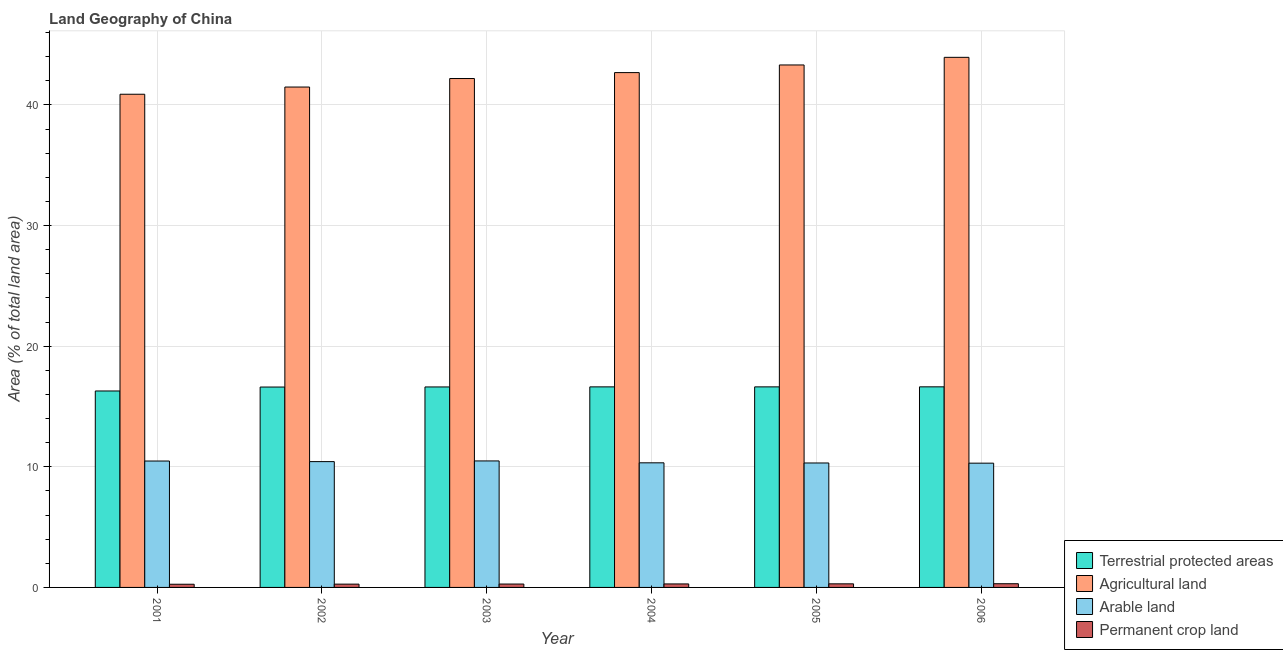How many groups of bars are there?
Provide a succinct answer. 6. Are the number of bars on each tick of the X-axis equal?
Keep it short and to the point. Yes. How many bars are there on the 5th tick from the left?
Give a very brief answer. 4. How many bars are there on the 1st tick from the right?
Provide a succinct answer. 4. In how many cases, is the number of bars for a given year not equal to the number of legend labels?
Offer a terse response. 0. What is the percentage of area under permanent crop land in 2004?
Provide a short and direct response. 0.29. Across all years, what is the maximum percentage of land under terrestrial protection?
Keep it short and to the point. 16.63. Across all years, what is the minimum percentage of area under permanent crop land?
Offer a terse response. 0.26. In which year was the percentage of area under permanent crop land minimum?
Keep it short and to the point. 2001. What is the total percentage of land under terrestrial protection in the graph?
Your answer should be compact. 99.41. What is the difference between the percentage of area under permanent crop land in 2002 and that in 2006?
Make the answer very short. -0.03. What is the difference between the percentage of area under arable land in 2003 and the percentage of area under agricultural land in 2001?
Offer a very short reply. 0.01. What is the average percentage of area under agricultural land per year?
Your answer should be very brief. 42.42. In the year 2002, what is the difference between the percentage of land under terrestrial protection and percentage of area under agricultural land?
Provide a short and direct response. 0. What is the ratio of the percentage of area under permanent crop land in 2004 to that in 2006?
Your answer should be very brief. 0.94. Is the difference between the percentage of area under agricultural land in 2003 and 2006 greater than the difference between the percentage of land under terrestrial protection in 2003 and 2006?
Provide a succinct answer. No. What is the difference between the highest and the second highest percentage of area under arable land?
Make the answer very short. 0.01. What is the difference between the highest and the lowest percentage of area under arable land?
Ensure brevity in your answer.  0.19. Is the sum of the percentage of area under agricultural land in 2001 and 2005 greater than the maximum percentage of area under arable land across all years?
Make the answer very short. Yes. Is it the case that in every year, the sum of the percentage of area under arable land and percentage of area under permanent crop land is greater than the sum of percentage of land under terrestrial protection and percentage of area under agricultural land?
Your answer should be very brief. No. What does the 2nd bar from the left in 2005 represents?
Keep it short and to the point. Agricultural land. What does the 3rd bar from the right in 2001 represents?
Your answer should be compact. Agricultural land. How many bars are there?
Give a very brief answer. 24. Are all the bars in the graph horizontal?
Offer a terse response. No. Are the values on the major ticks of Y-axis written in scientific E-notation?
Ensure brevity in your answer.  No. Does the graph contain grids?
Ensure brevity in your answer.  Yes. Where does the legend appear in the graph?
Make the answer very short. Bottom right. How are the legend labels stacked?
Provide a short and direct response. Vertical. What is the title of the graph?
Offer a very short reply. Land Geography of China. What is the label or title of the X-axis?
Offer a very short reply. Year. What is the label or title of the Y-axis?
Give a very brief answer. Area (% of total land area). What is the Area (% of total land area) in Terrestrial protected areas in 2001?
Offer a very short reply. 16.29. What is the Area (% of total land area) in Agricultural land in 2001?
Make the answer very short. 40.89. What is the Area (% of total land area) of Arable land in 2001?
Provide a succinct answer. 10.48. What is the Area (% of total land area) in Permanent crop land in 2001?
Offer a terse response. 0.26. What is the Area (% of total land area) of Terrestrial protected areas in 2002?
Your answer should be compact. 16.61. What is the Area (% of total land area) of Agricultural land in 2002?
Provide a succinct answer. 41.49. What is the Area (% of total land area) in Arable land in 2002?
Your answer should be compact. 10.43. What is the Area (% of total land area) of Permanent crop land in 2002?
Ensure brevity in your answer.  0.27. What is the Area (% of total land area) of Terrestrial protected areas in 2003?
Ensure brevity in your answer.  16.62. What is the Area (% of total land area) in Agricultural land in 2003?
Your answer should be compact. 42.19. What is the Area (% of total land area) in Arable land in 2003?
Your response must be concise. 10.49. What is the Area (% of total land area) of Permanent crop land in 2003?
Your answer should be very brief. 0.28. What is the Area (% of total land area) of Terrestrial protected areas in 2004?
Ensure brevity in your answer.  16.63. What is the Area (% of total land area) of Agricultural land in 2004?
Provide a short and direct response. 42.68. What is the Area (% of total land area) of Arable land in 2004?
Ensure brevity in your answer.  10.33. What is the Area (% of total land area) of Permanent crop land in 2004?
Your response must be concise. 0.29. What is the Area (% of total land area) of Terrestrial protected areas in 2005?
Offer a very short reply. 16.63. What is the Area (% of total land area) in Agricultural land in 2005?
Keep it short and to the point. 43.32. What is the Area (% of total land area) in Arable land in 2005?
Your response must be concise. 10.32. What is the Area (% of total land area) in Permanent crop land in 2005?
Your response must be concise. 0.3. What is the Area (% of total land area) in Terrestrial protected areas in 2006?
Provide a succinct answer. 16.63. What is the Area (% of total land area) in Agricultural land in 2006?
Your answer should be compact. 43.95. What is the Area (% of total land area) in Arable land in 2006?
Ensure brevity in your answer.  10.3. What is the Area (% of total land area) of Permanent crop land in 2006?
Ensure brevity in your answer.  0.31. Across all years, what is the maximum Area (% of total land area) in Terrestrial protected areas?
Your response must be concise. 16.63. Across all years, what is the maximum Area (% of total land area) in Agricultural land?
Your answer should be compact. 43.95. Across all years, what is the maximum Area (% of total land area) in Arable land?
Provide a short and direct response. 10.49. Across all years, what is the maximum Area (% of total land area) of Permanent crop land?
Your answer should be very brief. 0.31. Across all years, what is the minimum Area (% of total land area) of Terrestrial protected areas?
Offer a very short reply. 16.29. Across all years, what is the minimum Area (% of total land area) of Agricultural land?
Ensure brevity in your answer.  40.89. Across all years, what is the minimum Area (% of total land area) in Arable land?
Your answer should be very brief. 10.3. Across all years, what is the minimum Area (% of total land area) of Permanent crop land?
Your answer should be very brief. 0.26. What is the total Area (% of total land area) in Terrestrial protected areas in the graph?
Offer a very short reply. 99.41. What is the total Area (% of total land area) in Agricultural land in the graph?
Offer a very short reply. 254.51. What is the total Area (% of total land area) in Arable land in the graph?
Ensure brevity in your answer.  62.35. What is the total Area (% of total land area) in Permanent crop land in the graph?
Provide a short and direct response. 1.71. What is the difference between the Area (% of total land area) of Terrestrial protected areas in 2001 and that in 2002?
Provide a succinct answer. -0.33. What is the difference between the Area (% of total land area) of Agricultural land in 2001 and that in 2002?
Your answer should be compact. -0.6. What is the difference between the Area (% of total land area) in Arable land in 2001 and that in 2002?
Your answer should be very brief. 0.05. What is the difference between the Area (% of total land area) in Permanent crop land in 2001 and that in 2002?
Provide a succinct answer. -0.01. What is the difference between the Area (% of total land area) of Terrestrial protected areas in 2001 and that in 2003?
Give a very brief answer. -0.33. What is the difference between the Area (% of total land area) of Agricultural land in 2001 and that in 2003?
Keep it short and to the point. -1.3. What is the difference between the Area (% of total land area) of Arable land in 2001 and that in 2003?
Your response must be concise. -0.01. What is the difference between the Area (% of total land area) in Permanent crop land in 2001 and that in 2003?
Provide a succinct answer. -0.02. What is the difference between the Area (% of total land area) in Terrestrial protected areas in 2001 and that in 2004?
Offer a terse response. -0.34. What is the difference between the Area (% of total land area) in Agricultural land in 2001 and that in 2004?
Your answer should be compact. -1.79. What is the difference between the Area (% of total land area) of Arable land in 2001 and that in 2004?
Your response must be concise. 0.15. What is the difference between the Area (% of total land area) in Permanent crop land in 2001 and that in 2004?
Make the answer very short. -0.03. What is the difference between the Area (% of total land area) of Terrestrial protected areas in 2001 and that in 2005?
Provide a short and direct response. -0.34. What is the difference between the Area (% of total land area) in Agricultural land in 2001 and that in 2005?
Your answer should be very brief. -2.43. What is the difference between the Area (% of total land area) of Arable land in 2001 and that in 2005?
Make the answer very short. 0.16. What is the difference between the Area (% of total land area) in Permanent crop land in 2001 and that in 2005?
Provide a succinct answer. -0.03. What is the difference between the Area (% of total land area) in Terrestrial protected areas in 2001 and that in 2006?
Offer a very short reply. -0.34. What is the difference between the Area (% of total land area) of Agricultural land in 2001 and that in 2006?
Your answer should be very brief. -3.06. What is the difference between the Area (% of total land area) of Arable land in 2001 and that in 2006?
Your answer should be compact. 0.18. What is the difference between the Area (% of total land area) in Permanent crop land in 2001 and that in 2006?
Provide a short and direct response. -0.04. What is the difference between the Area (% of total land area) of Terrestrial protected areas in 2002 and that in 2003?
Your answer should be compact. -0.01. What is the difference between the Area (% of total land area) of Agricultural land in 2002 and that in 2003?
Make the answer very short. -0.71. What is the difference between the Area (% of total land area) of Arable land in 2002 and that in 2003?
Provide a short and direct response. -0.06. What is the difference between the Area (% of total land area) of Permanent crop land in 2002 and that in 2003?
Your response must be concise. -0.01. What is the difference between the Area (% of total land area) in Terrestrial protected areas in 2002 and that in 2004?
Give a very brief answer. -0.02. What is the difference between the Area (% of total land area) in Agricultural land in 2002 and that in 2004?
Offer a terse response. -1.2. What is the difference between the Area (% of total land area) of Arable land in 2002 and that in 2004?
Provide a succinct answer. 0.1. What is the difference between the Area (% of total land area) of Permanent crop land in 2002 and that in 2004?
Your answer should be compact. -0.02. What is the difference between the Area (% of total land area) in Terrestrial protected areas in 2002 and that in 2005?
Make the answer very short. -0.02. What is the difference between the Area (% of total land area) of Agricultural land in 2002 and that in 2005?
Provide a short and direct response. -1.83. What is the difference between the Area (% of total land area) in Arable land in 2002 and that in 2005?
Your answer should be compact. 0.11. What is the difference between the Area (% of total land area) of Permanent crop land in 2002 and that in 2005?
Make the answer very short. -0.03. What is the difference between the Area (% of total land area) of Terrestrial protected areas in 2002 and that in 2006?
Make the answer very short. -0.02. What is the difference between the Area (% of total land area) of Agricultural land in 2002 and that in 2006?
Give a very brief answer. -2.46. What is the difference between the Area (% of total land area) of Arable land in 2002 and that in 2006?
Keep it short and to the point. 0.13. What is the difference between the Area (% of total land area) of Permanent crop land in 2002 and that in 2006?
Your answer should be compact. -0.03. What is the difference between the Area (% of total land area) in Terrestrial protected areas in 2003 and that in 2004?
Give a very brief answer. -0.01. What is the difference between the Area (% of total land area) of Agricultural land in 2003 and that in 2004?
Your response must be concise. -0.49. What is the difference between the Area (% of total land area) in Arable land in 2003 and that in 2004?
Offer a terse response. 0.16. What is the difference between the Area (% of total land area) in Permanent crop land in 2003 and that in 2004?
Make the answer very short. -0.01. What is the difference between the Area (% of total land area) in Terrestrial protected areas in 2003 and that in 2005?
Your answer should be compact. -0.01. What is the difference between the Area (% of total land area) of Agricultural land in 2003 and that in 2005?
Offer a terse response. -1.12. What is the difference between the Area (% of total land area) of Arable land in 2003 and that in 2005?
Offer a very short reply. 0.17. What is the difference between the Area (% of total land area) in Permanent crop land in 2003 and that in 2005?
Your answer should be compact. -0.02. What is the difference between the Area (% of total land area) of Terrestrial protected areas in 2003 and that in 2006?
Offer a very short reply. -0.01. What is the difference between the Area (% of total land area) in Agricultural land in 2003 and that in 2006?
Offer a terse response. -1.76. What is the difference between the Area (% of total land area) of Arable land in 2003 and that in 2006?
Offer a very short reply. 0.19. What is the difference between the Area (% of total land area) in Permanent crop land in 2003 and that in 2006?
Your answer should be very brief. -0.03. What is the difference between the Area (% of total land area) in Terrestrial protected areas in 2004 and that in 2005?
Offer a very short reply. -0. What is the difference between the Area (% of total land area) in Agricultural land in 2004 and that in 2005?
Your answer should be compact. -0.63. What is the difference between the Area (% of total land area) in Arable land in 2004 and that in 2005?
Your answer should be compact. 0.01. What is the difference between the Area (% of total land area) in Permanent crop land in 2004 and that in 2005?
Ensure brevity in your answer.  -0.01. What is the difference between the Area (% of total land area) in Terrestrial protected areas in 2004 and that in 2006?
Give a very brief answer. -0. What is the difference between the Area (% of total land area) of Agricultural land in 2004 and that in 2006?
Keep it short and to the point. -1.27. What is the difference between the Area (% of total land area) of Arable land in 2004 and that in 2006?
Your answer should be very brief. 0.03. What is the difference between the Area (% of total land area) in Permanent crop land in 2004 and that in 2006?
Your answer should be compact. -0.02. What is the difference between the Area (% of total land area) of Terrestrial protected areas in 2005 and that in 2006?
Your response must be concise. -0. What is the difference between the Area (% of total land area) of Agricultural land in 2005 and that in 2006?
Your answer should be very brief. -0.63. What is the difference between the Area (% of total land area) in Arable land in 2005 and that in 2006?
Provide a short and direct response. 0.01. What is the difference between the Area (% of total land area) of Permanent crop land in 2005 and that in 2006?
Give a very brief answer. -0.01. What is the difference between the Area (% of total land area) of Terrestrial protected areas in 2001 and the Area (% of total land area) of Agricultural land in 2002?
Your answer should be very brief. -25.2. What is the difference between the Area (% of total land area) of Terrestrial protected areas in 2001 and the Area (% of total land area) of Arable land in 2002?
Your answer should be very brief. 5.86. What is the difference between the Area (% of total land area) of Terrestrial protected areas in 2001 and the Area (% of total land area) of Permanent crop land in 2002?
Make the answer very short. 16.01. What is the difference between the Area (% of total land area) in Agricultural land in 2001 and the Area (% of total land area) in Arable land in 2002?
Make the answer very short. 30.46. What is the difference between the Area (% of total land area) of Agricultural land in 2001 and the Area (% of total land area) of Permanent crop land in 2002?
Your answer should be very brief. 40.62. What is the difference between the Area (% of total land area) in Arable land in 2001 and the Area (% of total land area) in Permanent crop land in 2002?
Provide a short and direct response. 10.21. What is the difference between the Area (% of total land area) in Terrestrial protected areas in 2001 and the Area (% of total land area) in Agricultural land in 2003?
Make the answer very short. -25.9. What is the difference between the Area (% of total land area) of Terrestrial protected areas in 2001 and the Area (% of total land area) of Permanent crop land in 2003?
Make the answer very short. 16.01. What is the difference between the Area (% of total land area) in Agricultural land in 2001 and the Area (% of total land area) in Arable land in 2003?
Ensure brevity in your answer.  30.4. What is the difference between the Area (% of total land area) of Agricultural land in 2001 and the Area (% of total land area) of Permanent crop land in 2003?
Your response must be concise. 40.61. What is the difference between the Area (% of total land area) in Arable land in 2001 and the Area (% of total land area) in Permanent crop land in 2003?
Keep it short and to the point. 10.2. What is the difference between the Area (% of total land area) in Terrestrial protected areas in 2001 and the Area (% of total land area) in Agricultural land in 2004?
Offer a very short reply. -26.39. What is the difference between the Area (% of total land area) in Terrestrial protected areas in 2001 and the Area (% of total land area) in Arable land in 2004?
Your answer should be very brief. 5.96. What is the difference between the Area (% of total land area) of Terrestrial protected areas in 2001 and the Area (% of total land area) of Permanent crop land in 2004?
Your response must be concise. 16. What is the difference between the Area (% of total land area) in Agricultural land in 2001 and the Area (% of total land area) in Arable land in 2004?
Provide a succinct answer. 30.56. What is the difference between the Area (% of total land area) in Agricultural land in 2001 and the Area (% of total land area) in Permanent crop land in 2004?
Your answer should be compact. 40.6. What is the difference between the Area (% of total land area) of Arable land in 2001 and the Area (% of total land area) of Permanent crop land in 2004?
Make the answer very short. 10.19. What is the difference between the Area (% of total land area) in Terrestrial protected areas in 2001 and the Area (% of total land area) in Agricultural land in 2005?
Ensure brevity in your answer.  -27.03. What is the difference between the Area (% of total land area) of Terrestrial protected areas in 2001 and the Area (% of total land area) of Arable land in 2005?
Provide a short and direct response. 5.97. What is the difference between the Area (% of total land area) of Terrestrial protected areas in 2001 and the Area (% of total land area) of Permanent crop land in 2005?
Your answer should be very brief. 15.99. What is the difference between the Area (% of total land area) in Agricultural land in 2001 and the Area (% of total land area) in Arable land in 2005?
Offer a very short reply. 30.57. What is the difference between the Area (% of total land area) of Agricultural land in 2001 and the Area (% of total land area) of Permanent crop land in 2005?
Your response must be concise. 40.59. What is the difference between the Area (% of total land area) in Arable land in 2001 and the Area (% of total land area) in Permanent crop land in 2005?
Ensure brevity in your answer.  10.18. What is the difference between the Area (% of total land area) of Terrestrial protected areas in 2001 and the Area (% of total land area) of Agricultural land in 2006?
Provide a succinct answer. -27.66. What is the difference between the Area (% of total land area) of Terrestrial protected areas in 2001 and the Area (% of total land area) of Arable land in 2006?
Provide a short and direct response. 5.99. What is the difference between the Area (% of total land area) in Terrestrial protected areas in 2001 and the Area (% of total land area) in Permanent crop land in 2006?
Offer a terse response. 15.98. What is the difference between the Area (% of total land area) of Agricultural land in 2001 and the Area (% of total land area) of Arable land in 2006?
Make the answer very short. 30.59. What is the difference between the Area (% of total land area) of Agricultural land in 2001 and the Area (% of total land area) of Permanent crop land in 2006?
Your response must be concise. 40.58. What is the difference between the Area (% of total land area) in Arable land in 2001 and the Area (% of total land area) in Permanent crop land in 2006?
Give a very brief answer. 10.17. What is the difference between the Area (% of total land area) of Terrestrial protected areas in 2002 and the Area (% of total land area) of Agricultural land in 2003?
Offer a very short reply. -25.58. What is the difference between the Area (% of total land area) in Terrestrial protected areas in 2002 and the Area (% of total land area) in Arable land in 2003?
Give a very brief answer. 6.13. What is the difference between the Area (% of total land area) of Terrestrial protected areas in 2002 and the Area (% of total land area) of Permanent crop land in 2003?
Make the answer very short. 16.33. What is the difference between the Area (% of total land area) of Agricultural land in 2002 and the Area (% of total land area) of Arable land in 2003?
Your answer should be compact. 31. What is the difference between the Area (% of total land area) of Agricultural land in 2002 and the Area (% of total land area) of Permanent crop land in 2003?
Ensure brevity in your answer.  41.2. What is the difference between the Area (% of total land area) in Arable land in 2002 and the Area (% of total land area) in Permanent crop land in 2003?
Your answer should be compact. 10.15. What is the difference between the Area (% of total land area) in Terrestrial protected areas in 2002 and the Area (% of total land area) in Agricultural land in 2004?
Keep it short and to the point. -26.07. What is the difference between the Area (% of total land area) of Terrestrial protected areas in 2002 and the Area (% of total land area) of Arable land in 2004?
Keep it short and to the point. 6.28. What is the difference between the Area (% of total land area) in Terrestrial protected areas in 2002 and the Area (% of total land area) in Permanent crop land in 2004?
Offer a very short reply. 16.32. What is the difference between the Area (% of total land area) of Agricultural land in 2002 and the Area (% of total land area) of Arable land in 2004?
Keep it short and to the point. 31.15. What is the difference between the Area (% of total land area) in Agricultural land in 2002 and the Area (% of total land area) in Permanent crop land in 2004?
Your response must be concise. 41.2. What is the difference between the Area (% of total land area) of Arable land in 2002 and the Area (% of total land area) of Permanent crop land in 2004?
Your answer should be very brief. 10.14. What is the difference between the Area (% of total land area) of Terrestrial protected areas in 2002 and the Area (% of total land area) of Agricultural land in 2005?
Your answer should be very brief. -26.7. What is the difference between the Area (% of total land area) of Terrestrial protected areas in 2002 and the Area (% of total land area) of Arable land in 2005?
Keep it short and to the point. 6.3. What is the difference between the Area (% of total land area) in Terrestrial protected areas in 2002 and the Area (% of total land area) in Permanent crop land in 2005?
Keep it short and to the point. 16.31. What is the difference between the Area (% of total land area) in Agricultural land in 2002 and the Area (% of total land area) in Arable land in 2005?
Keep it short and to the point. 31.17. What is the difference between the Area (% of total land area) in Agricultural land in 2002 and the Area (% of total land area) in Permanent crop land in 2005?
Ensure brevity in your answer.  41.19. What is the difference between the Area (% of total land area) of Arable land in 2002 and the Area (% of total land area) of Permanent crop land in 2005?
Provide a succinct answer. 10.13. What is the difference between the Area (% of total land area) in Terrestrial protected areas in 2002 and the Area (% of total land area) in Agricultural land in 2006?
Offer a very short reply. -27.34. What is the difference between the Area (% of total land area) of Terrestrial protected areas in 2002 and the Area (% of total land area) of Arable land in 2006?
Make the answer very short. 6.31. What is the difference between the Area (% of total land area) of Terrestrial protected areas in 2002 and the Area (% of total land area) of Permanent crop land in 2006?
Give a very brief answer. 16.31. What is the difference between the Area (% of total land area) of Agricultural land in 2002 and the Area (% of total land area) of Arable land in 2006?
Provide a succinct answer. 31.18. What is the difference between the Area (% of total land area) of Agricultural land in 2002 and the Area (% of total land area) of Permanent crop land in 2006?
Offer a terse response. 41.18. What is the difference between the Area (% of total land area) of Arable land in 2002 and the Area (% of total land area) of Permanent crop land in 2006?
Provide a succinct answer. 10.12. What is the difference between the Area (% of total land area) in Terrestrial protected areas in 2003 and the Area (% of total land area) in Agricultural land in 2004?
Offer a very short reply. -26.06. What is the difference between the Area (% of total land area) of Terrestrial protected areas in 2003 and the Area (% of total land area) of Arable land in 2004?
Your answer should be compact. 6.29. What is the difference between the Area (% of total land area) in Terrestrial protected areas in 2003 and the Area (% of total land area) in Permanent crop land in 2004?
Keep it short and to the point. 16.33. What is the difference between the Area (% of total land area) of Agricultural land in 2003 and the Area (% of total land area) of Arable land in 2004?
Give a very brief answer. 31.86. What is the difference between the Area (% of total land area) of Agricultural land in 2003 and the Area (% of total land area) of Permanent crop land in 2004?
Provide a short and direct response. 41.9. What is the difference between the Area (% of total land area) of Arable land in 2003 and the Area (% of total land area) of Permanent crop land in 2004?
Your response must be concise. 10.2. What is the difference between the Area (% of total land area) in Terrestrial protected areas in 2003 and the Area (% of total land area) in Agricultural land in 2005?
Provide a short and direct response. -26.69. What is the difference between the Area (% of total land area) of Terrestrial protected areas in 2003 and the Area (% of total land area) of Arable land in 2005?
Provide a short and direct response. 6.3. What is the difference between the Area (% of total land area) in Terrestrial protected areas in 2003 and the Area (% of total land area) in Permanent crop land in 2005?
Make the answer very short. 16.32. What is the difference between the Area (% of total land area) in Agricultural land in 2003 and the Area (% of total land area) in Arable land in 2005?
Provide a short and direct response. 31.87. What is the difference between the Area (% of total land area) of Agricultural land in 2003 and the Area (% of total land area) of Permanent crop land in 2005?
Give a very brief answer. 41.89. What is the difference between the Area (% of total land area) in Arable land in 2003 and the Area (% of total land area) in Permanent crop land in 2005?
Keep it short and to the point. 10.19. What is the difference between the Area (% of total land area) of Terrestrial protected areas in 2003 and the Area (% of total land area) of Agricultural land in 2006?
Your answer should be compact. -27.33. What is the difference between the Area (% of total land area) in Terrestrial protected areas in 2003 and the Area (% of total land area) in Arable land in 2006?
Provide a short and direct response. 6.32. What is the difference between the Area (% of total land area) in Terrestrial protected areas in 2003 and the Area (% of total land area) in Permanent crop land in 2006?
Offer a very short reply. 16.31. What is the difference between the Area (% of total land area) of Agricultural land in 2003 and the Area (% of total land area) of Arable land in 2006?
Your response must be concise. 31.89. What is the difference between the Area (% of total land area) in Agricultural land in 2003 and the Area (% of total land area) in Permanent crop land in 2006?
Provide a short and direct response. 41.88. What is the difference between the Area (% of total land area) in Arable land in 2003 and the Area (% of total land area) in Permanent crop land in 2006?
Give a very brief answer. 10.18. What is the difference between the Area (% of total land area) in Terrestrial protected areas in 2004 and the Area (% of total land area) in Agricultural land in 2005?
Your answer should be compact. -26.69. What is the difference between the Area (% of total land area) in Terrestrial protected areas in 2004 and the Area (% of total land area) in Arable land in 2005?
Offer a very short reply. 6.31. What is the difference between the Area (% of total land area) of Terrestrial protected areas in 2004 and the Area (% of total land area) of Permanent crop land in 2005?
Offer a terse response. 16.33. What is the difference between the Area (% of total land area) in Agricultural land in 2004 and the Area (% of total land area) in Arable land in 2005?
Make the answer very short. 32.36. What is the difference between the Area (% of total land area) in Agricultural land in 2004 and the Area (% of total land area) in Permanent crop land in 2005?
Make the answer very short. 42.38. What is the difference between the Area (% of total land area) in Arable land in 2004 and the Area (% of total land area) in Permanent crop land in 2005?
Offer a terse response. 10.03. What is the difference between the Area (% of total land area) of Terrestrial protected areas in 2004 and the Area (% of total land area) of Agricultural land in 2006?
Your response must be concise. -27.32. What is the difference between the Area (% of total land area) of Terrestrial protected areas in 2004 and the Area (% of total land area) of Arable land in 2006?
Make the answer very short. 6.33. What is the difference between the Area (% of total land area) of Terrestrial protected areas in 2004 and the Area (% of total land area) of Permanent crop land in 2006?
Your answer should be very brief. 16.32. What is the difference between the Area (% of total land area) in Agricultural land in 2004 and the Area (% of total land area) in Arable land in 2006?
Your answer should be compact. 32.38. What is the difference between the Area (% of total land area) in Agricultural land in 2004 and the Area (% of total land area) in Permanent crop land in 2006?
Keep it short and to the point. 42.38. What is the difference between the Area (% of total land area) of Arable land in 2004 and the Area (% of total land area) of Permanent crop land in 2006?
Offer a terse response. 10.02. What is the difference between the Area (% of total land area) of Terrestrial protected areas in 2005 and the Area (% of total land area) of Agricultural land in 2006?
Make the answer very short. -27.32. What is the difference between the Area (% of total land area) in Terrestrial protected areas in 2005 and the Area (% of total land area) in Arable land in 2006?
Your answer should be very brief. 6.33. What is the difference between the Area (% of total land area) of Terrestrial protected areas in 2005 and the Area (% of total land area) of Permanent crop land in 2006?
Offer a very short reply. 16.32. What is the difference between the Area (% of total land area) of Agricultural land in 2005 and the Area (% of total land area) of Arable land in 2006?
Provide a short and direct response. 33.01. What is the difference between the Area (% of total land area) in Agricultural land in 2005 and the Area (% of total land area) in Permanent crop land in 2006?
Keep it short and to the point. 43.01. What is the difference between the Area (% of total land area) in Arable land in 2005 and the Area (% of total land area) in Permanent crop land in 2006?
Your response must be concise. 10.01. What is the average Area (% of total land area) of Terrestrial protected areas per year?
Offer a terse response. 16.57. What is the average Area (% of total land area) of Agricultural land per year?
Your answer should be compact. 42.42. What is the average Area (% of total land area) of Arable land per year?
Offer a very short reply. 10.39. What is the average Area (% of total land area) of Permanent crop land per year?
Offer a very short reply. 0.29. In the year 2001, what is the difference between the Area (% of total land area) of Terrestrial protected areas and Area (% of total land area) of Agricultural land?
Keep it short and to the point. -24.6. In the year 2001, what is the difference between the Area (% of total land area) in Terrestrial protected areas and Area (% of total land area) in Arable land?
Offer a very short reply. 5.81. In the year 2001, what is the difference between the Area (% of total land area) of Terrestrial protected areas and Area (% of total land area) of Permanent crop land?
Give a very brief answer. 16.02. In the year 2001, what is the difference between the Area (% of total land area) of Agricultural land and Area (% of total land area) of Arable land?
Make the answer very short. 30.41. In the year 2001, what is the difference between the Area (% of total land area) in Agricultural land and Area (% of total land area) in Permanent crop land?
Offer a very short reply. 40.62. In the year 2001, what is the difference between the Area (% of total land area) of Arable land and Area (% of total land area) of Permanent crop land?
Keep it short and to the point. 10.22. In the year 2002, what is the difference between the Area (% of total land area) in Terrestrial protected areas and Area (% of total land area) in Agricultural land?
Make the answer very short. -24.87. In the year 2002, what is the difference between the Area (% of total land area) of Terrestrial protected areas and Area (% of total land area) of Arable land?
Offer a very short reply. 6.18. In the year 2002, what is the difference between the Area (% of total land area) of Terrestrial protected areas and Area (% of total land area) of Permanent crop land?
Ensure brevity in your answer.  16.34. In the year 2002, what is the difference between the Area (% of total land area) in Agricultural land and Area (% of total land area) in Arable land?
Provide a succinct answer. 31.06. In the year 2002, what is the difference between the Area (% of total land area) in Agricultural land and Area (% of total land area) in Permanent crop land?
Your response must be concise. 41.21. In the year 2002, what is the difference between the Area (% of total land area) of Arable land and Area (% of total land area) of Permanent crop land?
Your answer should be compact. 10.16. In the year 2003, what is the difference between the Area (% of total land area) of Terrestrial protected areas and Area (% of total land area) of Agricultural land?
Ensure brevity in your answer.  -25.57. In the year 2003, what is the difference between the Area (% of total land area) of Terrestrial protected areas and Area (% of total land area) of Arable land?
Keep it short and to the point. 6.13. In the year 2003, what is the difference between the Area (% of total land area) in Terrestrial protected areas and Area (% of total land area) in Permanent crop land?
Your answer should be compact. 16.34. In the year 2003, what is the difference between the Area (% of total land area) in Agricultural land and Area (% of total land area) in Arable land?
Your response must be concise. 31.7. In the year 2003, what is the difference between the Area (% of total land area) in Agricultural land and Area (% of total land area) in Permanent crop land?
Provide a succinct answer. 41.91. In the year 2003, what is the difference between the Area (% of total land area) in Arable land and Area (% of total land area) in Permanent crop land?
Provide a succinct answer. 10.21. In the year 2004, what is the difference between the Area (% of total land area) in Terrestrial protected areas and Area (% of total land area) in Agricultural land?
Your answer should be compact. -26.05. In the year 2004, what is the difference between the Area (% of total land area) of Terrestrial protected areas and Area (% of total land area) of Arable land?
Offer a terse response. 6.3. In the year 2004, what is the difference between the Area (% of total land area) of Terrestrial protected areas and Area (% of total land area) of Permanent crop land?
Your answer should be very brief. 16.34. In the year 2004, what is the difference between the Area (% of total land area) in Agricultural land and Area (% of total land area) in Arable land?
Ensure brevity in your answer.  32.35. In the year 2004, what is the difference between the Area (% of total land area) of Agricultural land and Area (% of total land area) of Permanent crop land?
Ensure brevity in your answer.  42.39. In the year 2004, what is the difference between the Area (% of total land area) in Arable land and Area (% of total land area) in Permanent crop land?
Offer a terse response. 10.04. In the year 2005, what is the difference between the Area (% of total land area) in Terrestrial protected areas and Area (% of total land area) in Agricultural land?
Offer a very short reply. -26.69. In the year 2005, what is the difference between the Area (% of total land area) of Terrestrial protected areas and Area (% of total land area) of Arable land?
Give a very brief answer. 6.31. In the year 2005, what is the difference between the Area (% of total land area) of Terrestrial protected areas and Area (% of total land area) of Permanent crop land?
Your answer should be very brief. 16.33. In the year 2005, what is the difference between the Area (% of total land area) of Agricultural land and Area (% of total land area) of Arable land?
Give a very brief answer. 33. In the year 2005, what is the difference between the Area (% of total land area) of Agricultural land and Area (% of total land area) of Permanent crop land?
Your answer should be compact. 43.02. In the year 2005, what is the difference between the Area (% of total land area) of Arable land and Area (% of total land area) of Permanent crop land?
Your response must be concise. 10.02. In the year 2006, what is the difference between the Area (% of total land area) in Terrestrial protected areas and Area (% of total land area) in Agricultural land?
Make the answer very short. -27.32. In the year 2006, what is the difference between the Area (% of total land area) in Terrestrial protected areas and Area (% of total land area) in Arable land?
Provide a short and direct response. 6.33. In the year 2006, what is the difference between the Area (% of total land area) of Terrestrial protected areas and Area (% of total land area) of Permanent crop land?
Offer a terse response. 16.32. In the year 2006, what is the difference between the Area (% of total land area) in Agricultural land and Area (% of total land area) in Arable land?
Keep it short and to the point. 33.65. In the year 2006, what is the difference between the Area (% of total land area) of Agricultural land and Area (% of total land area) of Permanent crop land?
Your answer should be very brief. 43.64. In the year 2006, what is the difference between the Area (% of total land area) of Arable land and Area (% of total land area) of Permanent crop land?
Your response must be concise. 10. What is the ratio of the Area (% of total land area) of Terrestrial protected areas in 2001 to that in 2002?
Your answer should be very brief. 0.98. What is the ratio of the Area (% of total land area) in Agricultural land in 2001 to that in 2002?
Make the answer very short. 0.99. What is the ratio of the Area (% of total land area) of Arable land in 2001 to that in 2002?
Your answer should be compact. 1. What is the ratio of the Area (% of total land area) of Permanent crop land in 2001 to that in 2002?
Your answer should be compact. 0.97. What is the ratio of the Area (% of total land area) in Terrestrial protected areas in 2001 to that in 2003?
Keep it short and to the point. 0.98. What is the ratio of the Area (% of total land area) of Agricultural land in 2001 to that in 2003?
Offer a terse response. 0.97. What is the ratio of the Area (% of total land area) of Arable land in 2001 to that in 2003?
Your answer should be compact. 1. What is the ratio of the Area (% of total land area) of Permanent crop land in 2001 to that in 2003?
Ensure brevity in your answer.  0.94. What is the ratio of the Area (% of total land area) of Terrestrial protected areas in 2001 to that in 2004?
Your response must be concise. 0.98. What is the ratio of the Area (% of total land area) in Agricultural land in 2001 to that in 2004?
Keep it short and to the point. 0.96. What is the ratio of the Area (% of total land area) in Arable land in 2001 to that in 2004?
Offer a very short reply. 1.01. What is the ratio of the Area (% of total land area) of Permanent crop land in 2001 to that in 2004?
Offer a terse response. 0.91. What is the ratio of the Area (% of total land area) in Terrestrial protected areas in 2001 to that in 2005?
Ensure brevity in your answer.  0.98. What is the ratio of the Area (% of total land area) in Agricultural land in 2001 to that in 2005?
Your response must be concise. 0.94. What is the ratio of the Area (% of total land area) in Arable land in 2001 to that in 2005?
Keep it short and to the point. 1.02. What is the ratio of the Area (% of total land area) of Permanent crop land in 2001 to that in 2005?
Your answer should be very brief. 0.89. What is the ratio of the Area (% of total land area) of Terrestrial protected areas in 2001 to that in 2006?
Provide a succinct answer. 0.98. What is the ratio of the Area (% of total land area) of Agricultural land in 2001 to that in 2006?
Make the answer very short. 0.93. What is the ratio of the Area (% of total land area) in Arable land in 2001 to that in 2006?
Offer a very short reply. 1.02. What is the ratio of the Area (% of total land area) in Permanent crop land in 2001 to that in 2006?
Provide a short and direct response. 0.86. What is the ratio of the Area (% of total land area) in Terrestrial protected areas in 2002 to that in 2003?
Offer a terse response. 1. What is the ratio of the Area (% of total land area) in Agricultural land in 2002 to that in 2003?
Provide a short and direct response. 0.98. What is the ratio of the Area (% of total land area) in Permanent crop land in 2002 to that in 2003?
Make the answer very short. 0.97. What is the ratio of the Area (% of total land area) of Agricultural land in 2002 to that in 2004?
Provide a short and direct response. 0.97. What is the ratio of the Area (% of total land area) in Arable land in 2002 to that in 2004?
Make the answer very short. 1.01. What is the ratio of the Area (% of total land area) of Permanent crop land in 2002 to that in 2004?
Ensure brevity in your answer.  0.94. What is the ratio of the Area (% of total land area) in Terrestrial protected areas in 2002 to that in 2005?
Your answer should be compact. 1. What is the ratio of the Area (% of total land area) in Agricultural land in 2002 to that in 2005?
Offer a very short reply. 0.96. What is the ratio of the Area (% of total land area) in Arable land in 2002 to that in 2005?
Your answer should be compact. 1.01. What is the ratio of the Area (% of total land area) in Permanent crop land in 2002 to that in 2005?
Provide a short and direct response. 0.91. What is the ratio of the Area (% of total land area) in Agricultural land in 2002 to that in 2006?
Your response must be concise. 0.94. What is the ratio of the Area (% of total land area) in Arable land in 2002 to that in 2006?
Keep it short and to the point. 1.01. What is the ratio of the Area (% of total land area) in Permanent crop land in 2002 to that in 2006?
Your answer should be compact. 0.89. What is the ratio of the Area (% of total land area) in Terrestrial protected areas in 2003 to that in 2004?
Your answer should be very brief. 1. What is the ratio of the Area (% of total land area) of Arable land in 2003 to that in 2004?
Give a very brief answer. 1.02. What is the ratio of the Area (% of total land area) in Permanent crop land in 2003 to that in 2004?
Your answer should be compact. 0.97. What is the ratio of the Area (% of total land area) of Terrestrial protected areas in 2003 to that in 2005?
Provide a succinct answer. 1. What is the ratio of the Area (% of total land area) of Arable land in 2003 to that in 2005?
Your answer should be compact. 1.02. What is the ratio of the Area (% of total land area) in Permanent crop land in 2003 to that in 2005?
Your answer should be compact. 0.94. What is the ratio of the Area (% of total land area) of Agricultural land in 2003 to that in 2006?
Give a very brief answer. 0.96. What is the ratio of the Area (% of total land area) of Arable land in 2003 to that in 2006?
Offer a very short reply. 1.02. What is the ratio of the Area (% of total land area) in Terrestrial protected areas in 2004 to that in 2005?
Your answer should be very brief. 1. What is the ratio of the Area (% of total land area) of Agricultural land in 2004 to that in 2005?
Give a very brief answer. 0.99. What is the ratio of the Area (% of total land area) in Arable land in 2004 to that in 2005?
Give a very brief answer. 1. What is the ratio of the Area (% of total land area) of Permanent crop land in 2004 to that in 2005?
Provide a short and direct response. 0.97. What is the ratio of the Area (% of total land area) of Agricultural land in 2004 to that in 2006?
Your answer should be very brief. 0.97. What is the ratio of the Area (% of total land area) of Arable land in 2004 to that in 2006?
Keep it short and to the point. 1. What is the ratio of the Area (% of total land area) of Permanent crop land in 2004 to that in 2006?
Keep it short and to the point. 0.94. What is the ratio of the Area (% of total land area) of Terrestrial protected areas in 2005 to that in 2006?
Your response must be concise. 1. What is the ratio of the Area (% of total land area) in Agricultural land in 2005 to that in 2006?
Your response must be concise. 0.99. What is the ratio of the Area (% of total land area) of Arable land in 2005 to that in 2006?
Ensure brevity in your answer.  1. What is the ratio of the Area (% of total land area) of Permanent crop land in 2005 to that in 2006?
Offer a terse response. 0.97. What is the difference between the highest and the second highest Area (% of total land area) of Terrestrial protected areas?
Your response must be concise. 0. What is the difference between the highest and the second highest Area (% of total land area) of Agricultural land?
Offer a very short reply. 0.63. What is the difference between the highest and the second highest Area (% of total land area) in Arable land?
Keep it short and to the point. 0.01. What is the difference between the highest and the second highest Area (% of total land area) of Permanent crop land?
Ensure brevity in your answer.  0.01. What is the difference between the highest and the lowest Area (% of total land area) in Terrestrial protected areas?
Your answer should be very brief. 0.34. What is the difference between the highest and the lowest Area (% of total land area) in Agricultural land?
Provide a short and direct response. 3.06. What is the difference between the highest and the lowest Area (% of total land area) in Arable land?
Your answer should be compact. 0.19. What is the difference between the highest and the lowest Area (% of total land area) of Permanent crop land?
Your answer should be compact. 0.04. 